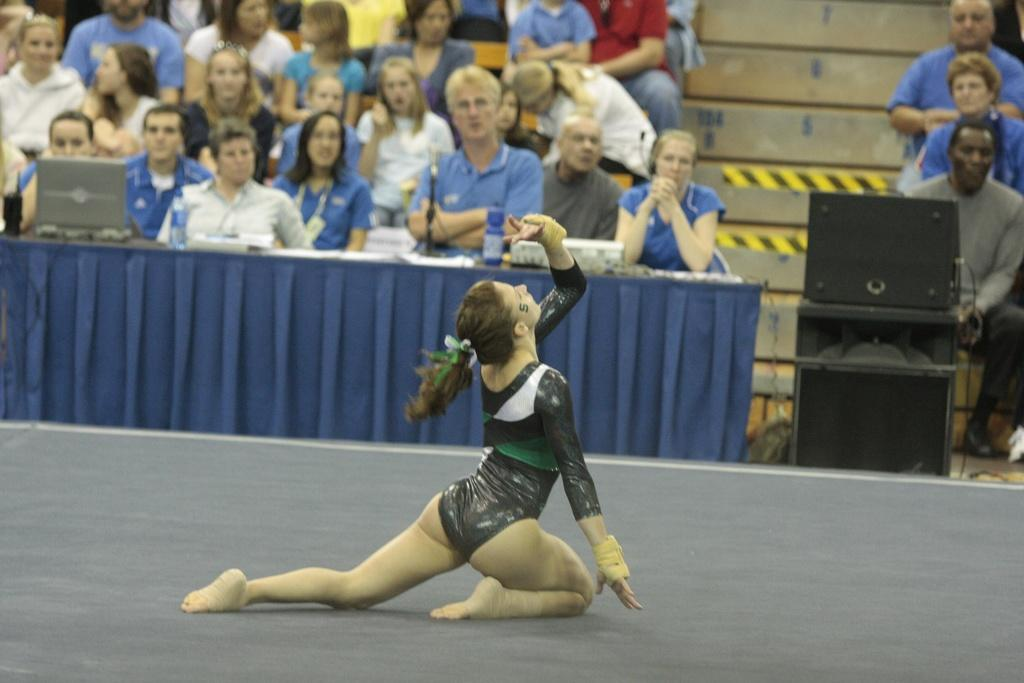What is the woman doing in the image? The woman is on the floor in the image. What can be seen in the background of the image? There is a group of people sitting in the background of the image. What electronic device is visible in the image? A laptop is visible in the image. What type of material is present in the image? Cloth is present in the image. What type of containers are visible in the image? Bottles are visible in the image. What other objects can be seen in the image? There are some objects in the image, including boxes. What type of electrical components are visible in the image? Wires are visible in the image. What type of structure is present in the image? There is a wall in the image. What type of trees can be seen in the image? There are no trees present in the image. Is there a ball visible in the image? There is no ball present in the image. 